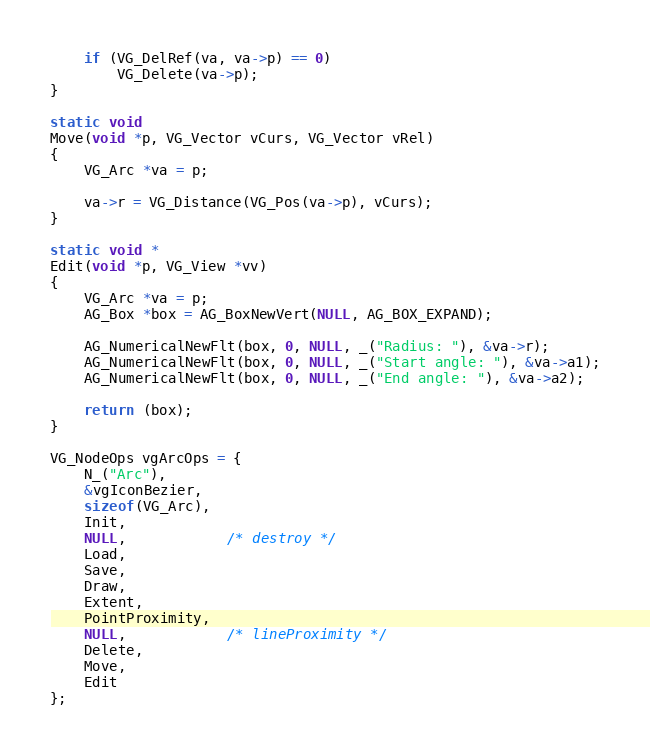<code> <loc_0><loc_0><loc_500><loc_500><_C_>
	if (VG_DelRef(va, va->p) == 0)
		VG_Delete(va->p);
}

static void
Move(void *p, VG_Vector vCurs, VG_Vector vRel)
{
	VG_Arc *va = p;

	va->r = VG_Distance(VG_Pos(va->p), vCurs);
}

static void *
Edit(void *p, VG_View *vv)
{
	VG_Arc *va = p;
	AG_Box *box = AG_BoxNewVert(NULL, AG_BOX_EXPAND);

	AG_NumericalNewFlt(box, 0, NULL, _("Radius: "), &va->r);
	AG_NumericalNewFlt(box, 0, NULL, _("Start angle: "), &va->a1);
	AG_NumericalNewFlt(box, 0, NULL, _("End angle: "), &va->a2);

	return (box);
}

VG_NodeOps vgArcOps = {
	N_("Arc"),
	&vgIconBezier,
	sizeof(VG_Arc),
	Init,
	NULL,			/* destroy */
	Load,
	Save,
	Draw,
	Extent,
	PointProximity,
	NULL,			/* lineProximity */
	Delete,
	Move,
	Edit
};
</code> 